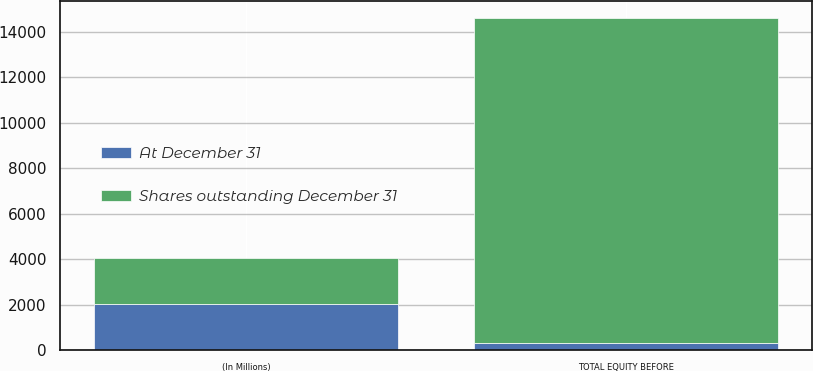<chart> <loc_0><loc_0><loc_500><loc_500><stacked_bar_chart><ecel><fcel>(In Millions)<fcel>TOTAL EQUITY BEFORE<nl><fcel>At December 31<fcel>2016<fcel>305<nl><fcel>Shares outstanding December 31<fcel>2016<fcel>14325<nl></chart> 